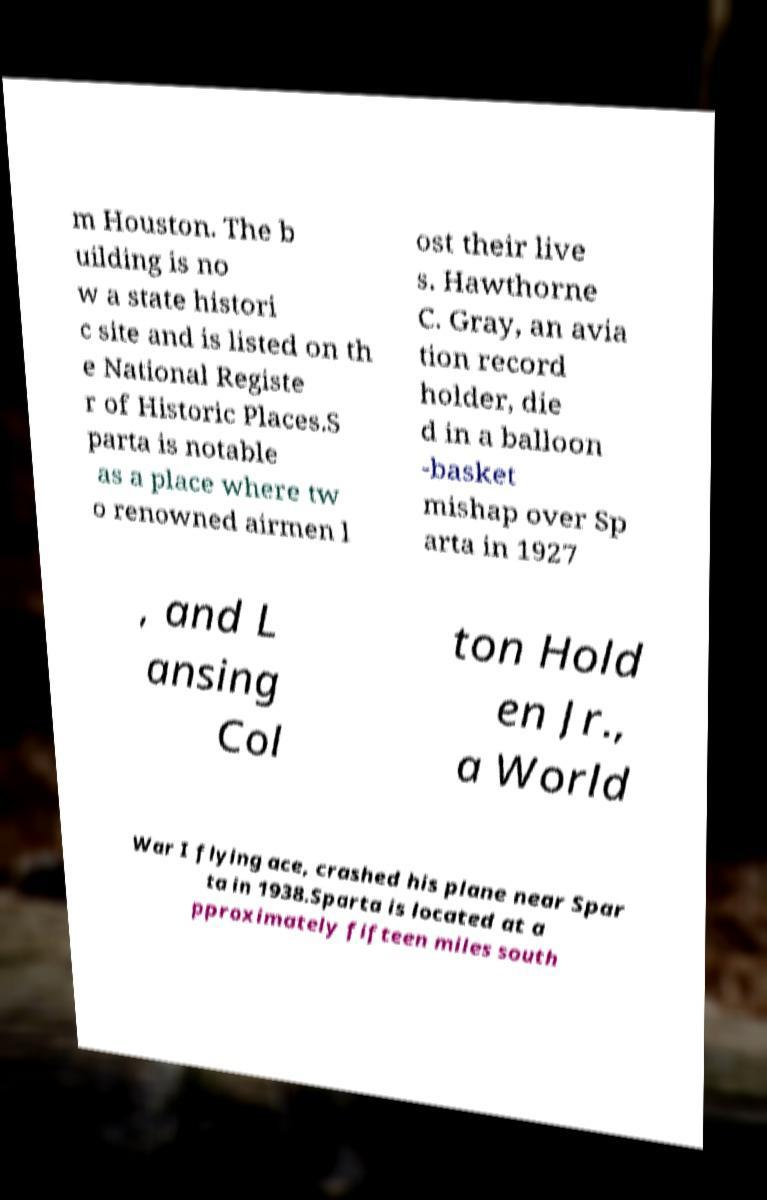Could you extract and type out the text from this image? m Houston. The b uilding is no w a state histori c site and is listed on th e National Registe r of Historic Places.S parta is notable as a place where tw o renowned airmen l ost their live s. Hawthorne C. Gray, an avia tion record holder, die d in a balloon -basket mishap over Sp arta in 1927 , and L ansing Col ton Hold en Jr., a World War I flying ace, crashed his plane near Spar ta in 1938.Sparta is located at a pproximately fifteen miles south 